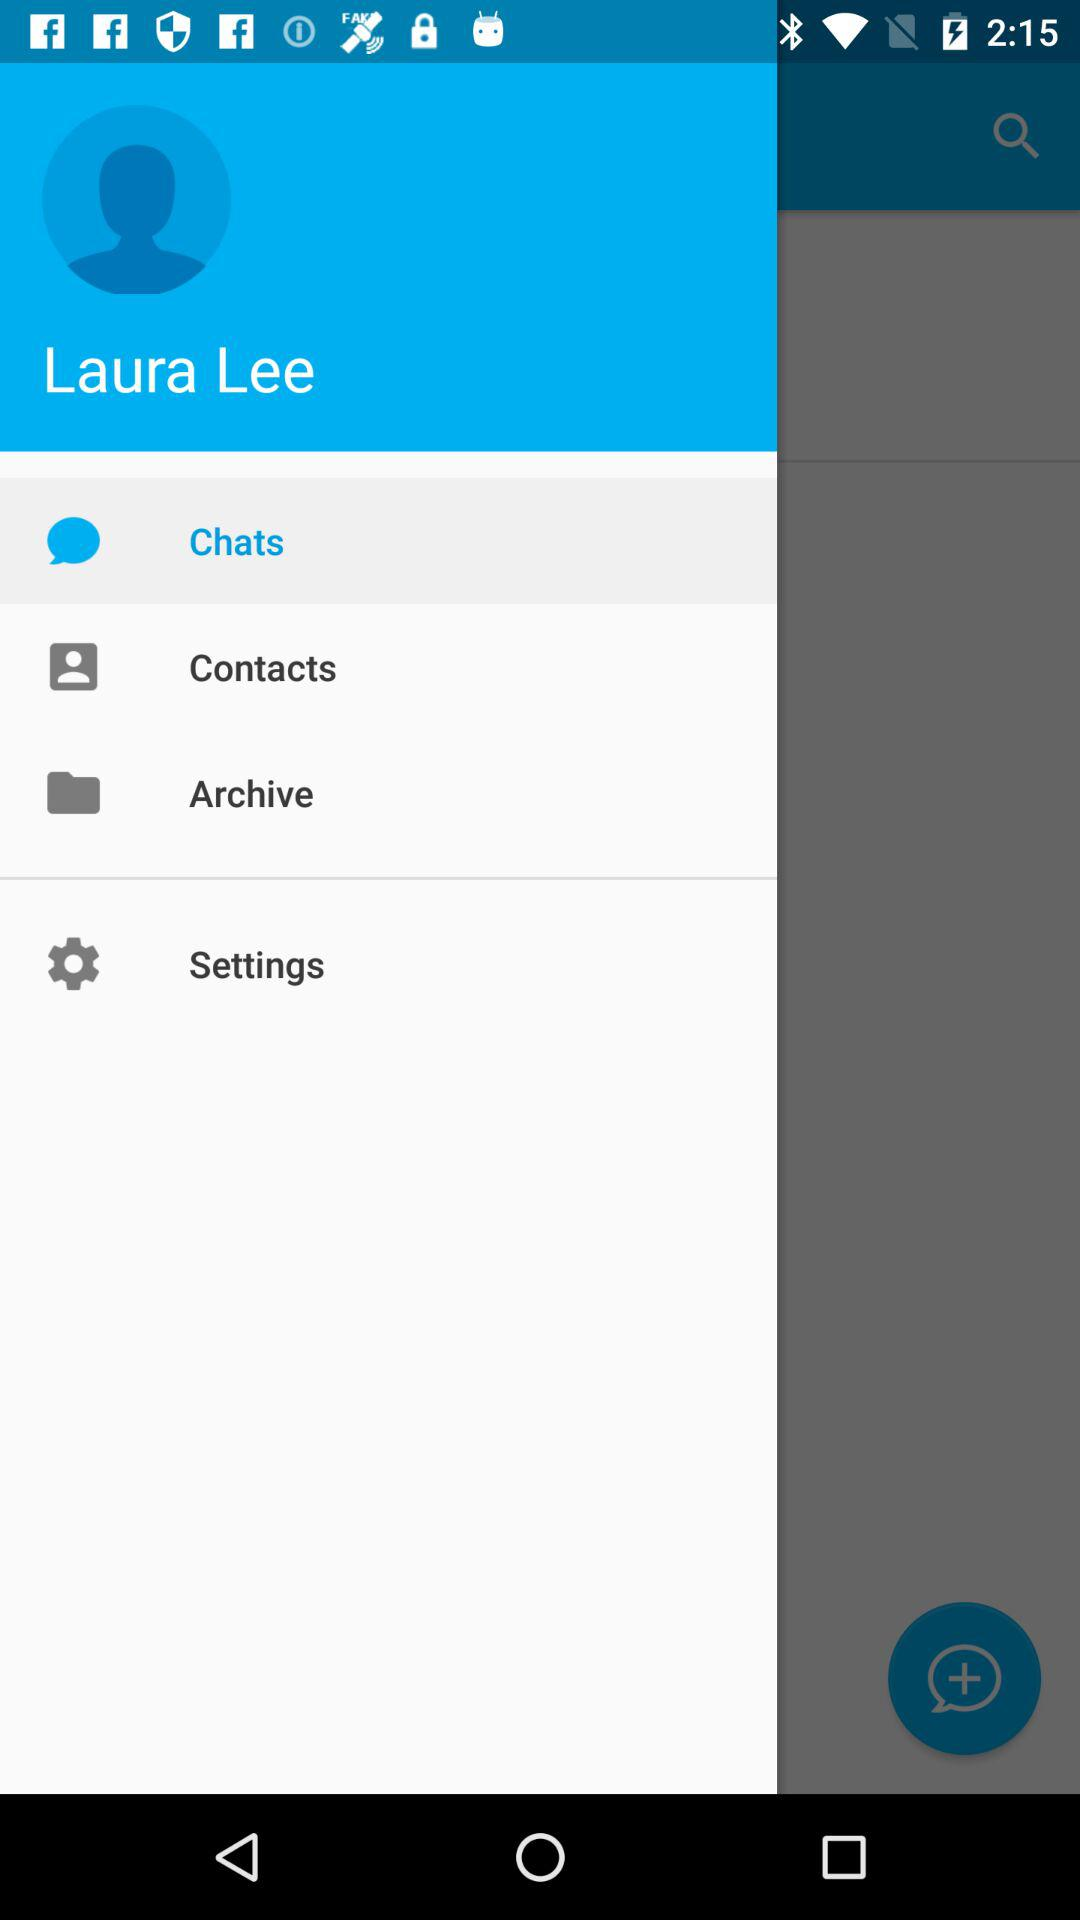What tab is selected? The selected tab is "Chats". 